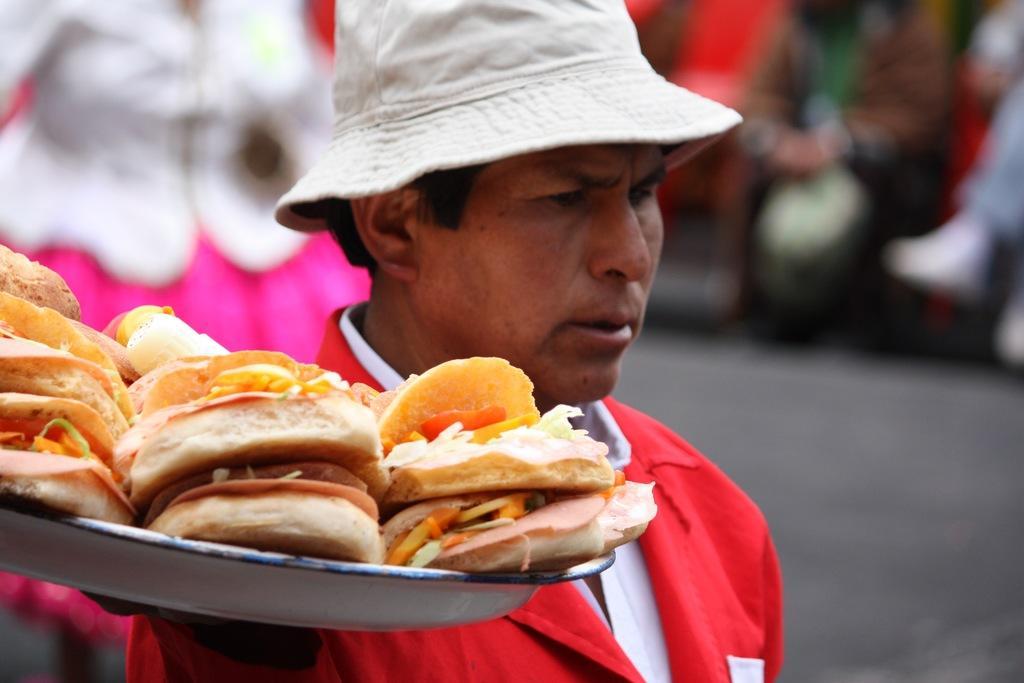How would you summarize this image in a sentence or two? A person is holding food item in the container. 